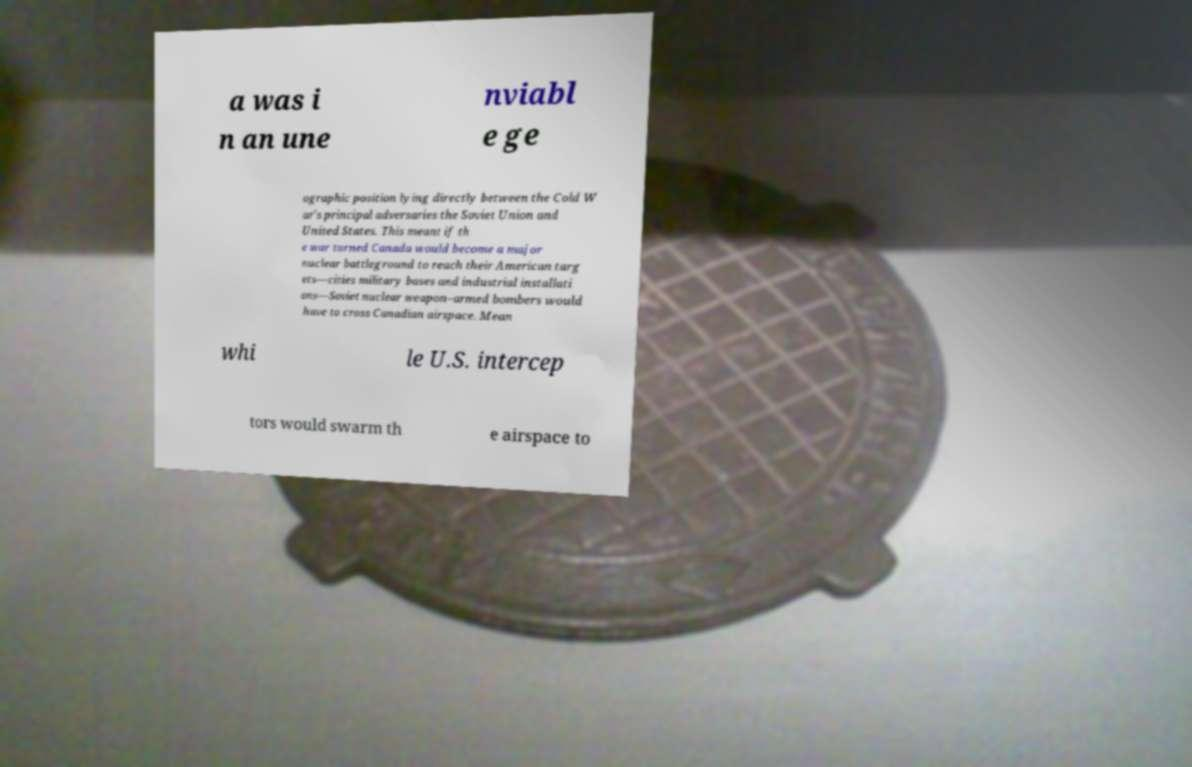Can you read and provide the text displayed in the image?This photo seems to have some interesting text. Can you extract and type it out for me? a was i n an une nviabl e ge ographic position lying directly between the Cold W ar's principal adversaries the Soviet Union and United States. This meant if th e war turned Canada would become a major nuclear battleground to reach their American targ ets—cities military bases and industrial installati ons—Soviet nuclear weapon–armed bombers would have to cross Canadian airspace. Mean whi le U.S. intercep tors would swarm th e airspace to 